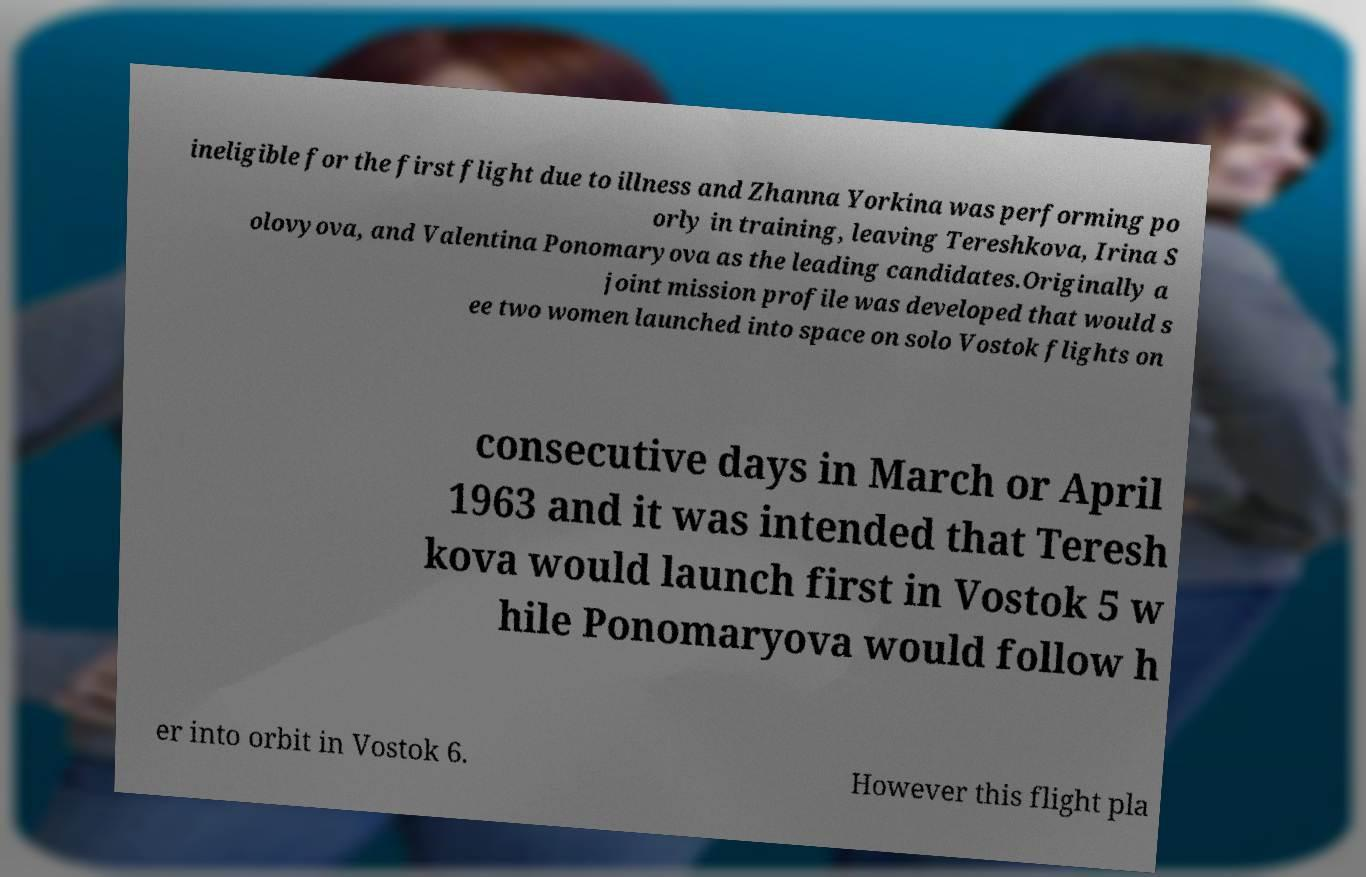Can you read and provide the text displayed in the image?This photo seems to have some interesting text. Can you extract and type it out for me? ineligible for the first flight due to illness and Zhanna Yorkina was performing po orly in training, leaving Tereshkova, Irina S olovyova, and Valentina Ponomaryova as the leading candidates.Originally a joint mission profile was developed that would s ee two women launched into space on solo Vostok flights on consecutive days in March or April 1963 and it was intended that Teresh kova would launch first in Vostok 5 w hile Ponomaryova would follow h er into orbit in Vostok 6. However this flight pla 